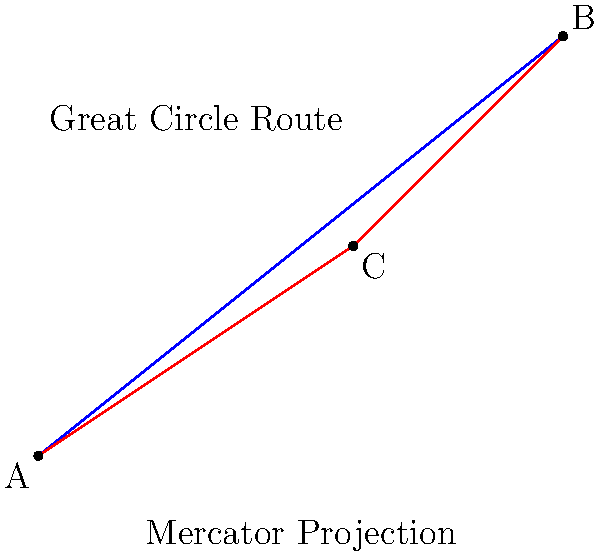As a book editor preparing a comprehensive atlas, you encounter a challenge in representing the shortest route between two points on a map. Given that the Mercator projection distorts distances, especially at higher latitudes, which route shown in the diagram would likely represent the true shortest path between points A and B, and why? To determine the shortest route between two points on a globe, we need to consider the following:

1. The Mercator projection, while useful for navigation, distorts distances, especially near the poles. It represents the Earth as a flat surface, which is not accurate for measuring distances.

2. The blue line represents the straight line on the Mercator projection, which would appear to be the shortest route on a flat map.

3. The red line, passing through point C, represents the Great Circle route. A Great Circle is the intersection of a sphere with a plane passing through the center of the sphere.

4. On a globe, the shortest distance between two points is always along a Great Circle arc.

5. The Great Circle route may appear curved on a flat map projection, but it actually represents the shortest path on the curved surface of the Earth.

6. The difference between the Mercator route and the Great Circle route becomes more pronounced at higher latitudes and for longer distances.

Therefore, the red line (Great Circle route) would likely represent the true shortest path between points A and B on the Earth's surface, despite appearing longer on the flat Mercator projection.
Answer: The red line (Great Circle route) 